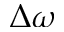Convert formula to latex. <formula><loc_0><loc_0><loc_500><loc_500>\Delta \omega</formula> 